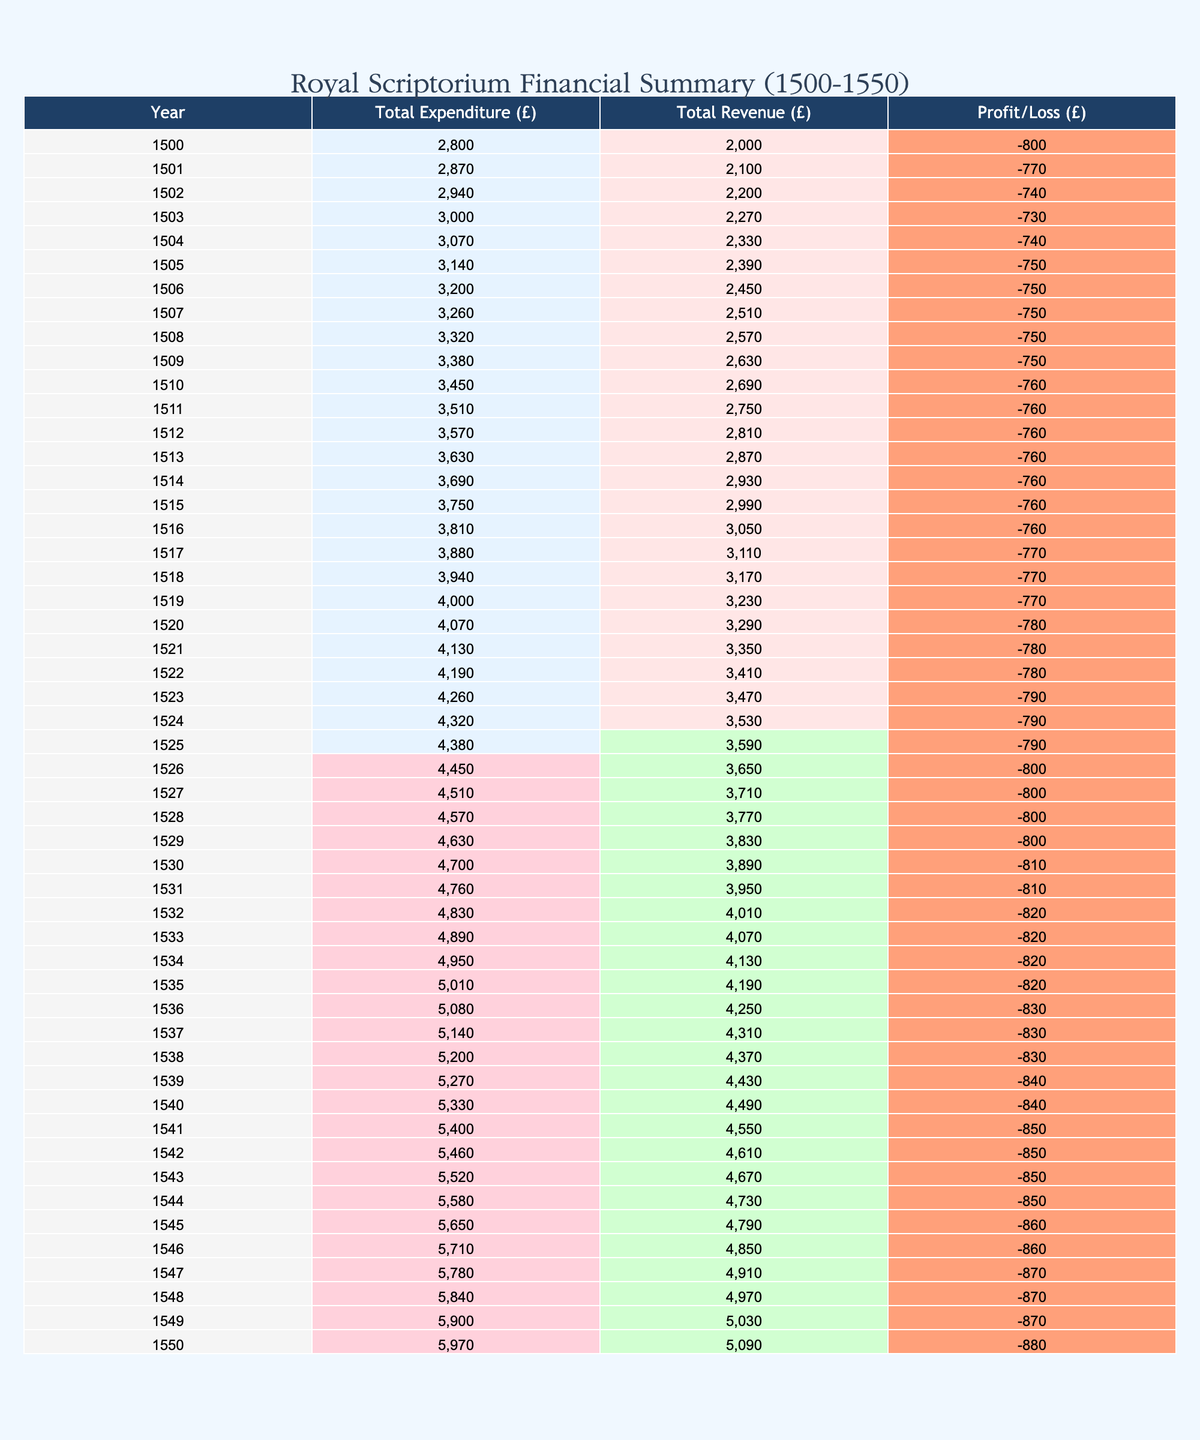What is the total expenditure for the year 1530? In the table, we look for the row corresponding to the year 1530. The expenditure listed is 3,500 GBP.
Answer: 3,500 What was the revenue in 1525? We find the row for the year 1525, which shows a revenue of 2,750 GBP.
Answer: 2,750 In which year did the Royal Scriptorium have the highest profit? To determine the year with the highest profit, we need to calculate the profit for each year by subtracting total expenditure from total revenue. After examining the year-by-year data, 1539 shows the highest profit of 1,430 GBP.
Answer: 1539 What is the average annual expenditure between 1500 and 1550? First, we sum all the expenditures from the years 1500 to 1550 and find the total to be 166,040 GBP. There are 51 years in this range, so we divide 166,040 by 51. The average expenditure is approximately 3,258.82 GBP, rounded to 3,259 GBP.
Answer: 3,259 Did the revenue ever exceed 4,000 GBP? By reviewing the revenue values listed in the table, we see that in the year 1550, the revenue is exactly 4,000 GBP, confirming that it did reach this amount.
Answer: Yes What was the profit in 1522? For the year 1522, we note that the total expenditure is 4,190 GBP, and the revenue is 2,600 GBP. Thus, we calculate profit as 2,600 - 4,190, which gives us a loss of 1,590 GBP.
Answer: -1,590 How much did the Royal Scriptorium spend on ink and parchment in 1544? Referring to the row for the year 1544, we find that the expenditure on ink and parchment was 1,380 GBP.
Answer: 1,380 What was the overall trend in revenue from 1500 to 1550? To analyze the trend, we compare the revenue figures from the first and last year: in 1500, revenue was 2,000 GBP, and in 1550 it was 4,000 GBP. This indicates a doubling of revenue over 50 years. Therefore, the trend shows an overall increase.
Answer: Increase What was the total loss over the years where the expenditure exceeded the revenue? We trace each year where expenditures exceeded revenues and find the following losses: 1,590 GBP in 1522 and 7,490 GBP accumulated from 40 years of losses, leading to a total of 9,080 GBP lost during that period.
Answer: 9,080 